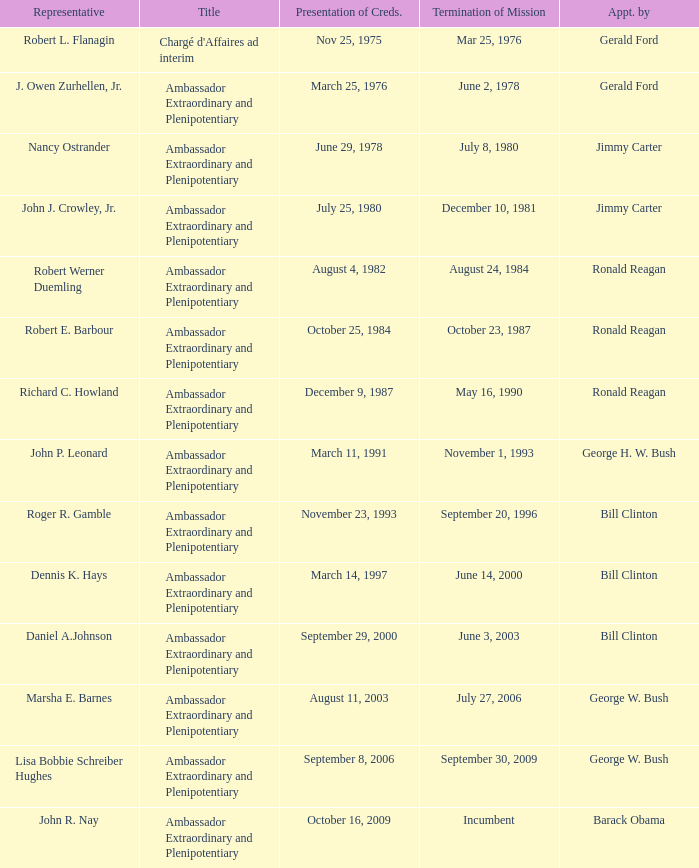Who appointed the representative that had a Presentation of Credentials on March 25, 1976? Gerald Ford. I'm looking to parse the entire table for insights. Could you assist me with that? {'header': ['Representative', 'Title', 'Presentation of Creds.', 'Termination of Mission', 'Appt. by'], 'rows': [['Robert L. Flanagin', "Chargé d'Affaires ad interim", 'Nov 25, 1975', 'Mar 25, 1976', 'Gerald Ford'], ['J. Owen Zurhellen, Jr.', 'Ambassador Extraordinary and Plenipotentiary', 'March 25, 1976', 'June 2, 1978', 'Gerald Ford'], ['Nancy Ostrander', 'Ambassador Extraordinary and Plenipotentiary', 'June 29, 1978', 'July 8, 1980', 'Jimmy Carter'], ['John J. Crowley, Jr.', 'Ambassador Extraordinary and Plenipotentiary', 'July 25, 1980', 'December 10, 1981', 'Jimmy Carter'], ['Robert Werner Duemling', 'Ambassador Extraordinary and Plenipotentiary', 'August 4, 1982', 'August 24, 1984', 'Ronald Reagan'], ['Robert E. Barbour', 'Ambassador Extraordinary and Plenipotentiary', 'October 25, 1984', 'October 23, 1987', 'Ronald Reagan'], ['Richard C. Howland', 'Ambassador Extraordinary and Plenipotentiary', 'December 9, 1987', 'May 16, 1990', 'Ronald Reagan'], ['John P. Leonard', 'Ambassador Extraordinary and Plenipotentiary', 'March 11, 1991', 'November 1, 1993', 'George H. W. Bush'], ['Roger R. Gamble', 'Ambassador Extraordinary and Plenipotentiary', 'November 23, 1993', 'September 20, 1996', 'Bill Clinton'], ['Dennis K. Hays', 'Ambassador Extraordinary and Plenipotentiary', 'March 14, 1997', 'June 14, 2000', 'Bill Clinton'], ['Daniel A.Johnson', 'Ambassador Extraordinary and Plenipotentiary', 'September 29, 2000', 'June 3, 2003', 'Bill Clinton'], ['Marsha E. Barnes', 'Ambassador Extraordinary and Plenipotentiary', 'August 11, 2003', 'July 27, 2006', 'George W. Bush'], ['Lisa Bobbie Schreiber Hughes', 'Ambassador Extraordinary and Plenipotentiary', 'September 8, 2006', 'September 30, 2009', 'George W. Bush'], ['John R. Nay', 'Ambassador Extraordinary and Plenipotentiary', 'October 16, 2009', 'Incumbent', 'Barack Obama']]} 